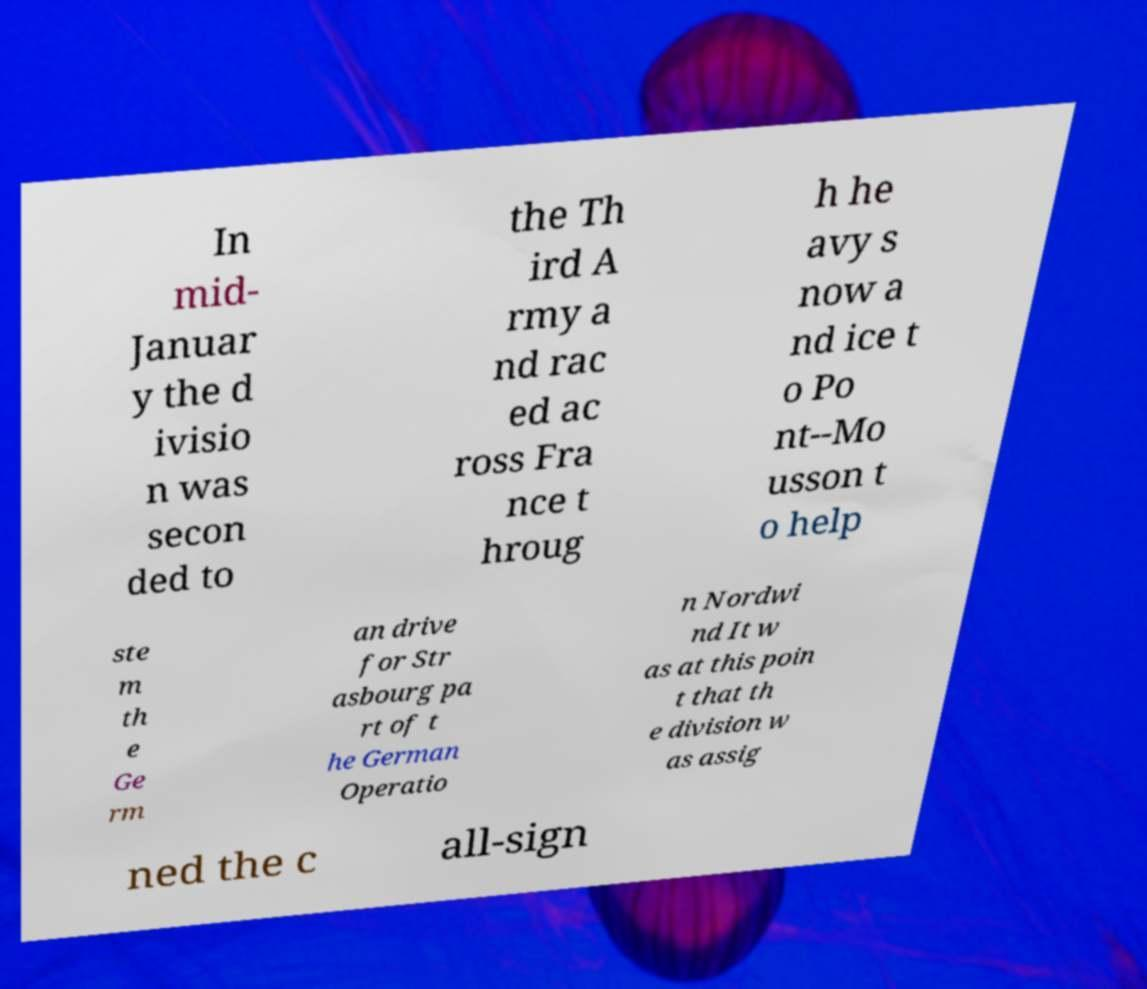Please read and relay the text visible in this image. What does it say? In mid- Januar y the d ivisio n was secon ded to the Th ird A rmy a nd rac ed ac ross Fra nce t hroug h he avy s now a nd ice t o Po nt--Mo usson t o help ste m th e Ge rm an drive for Str asbourg pa rt of t he German Operatio n Nordwi nd It w as at this poin t that th e division w as assig ned the c all-sign 